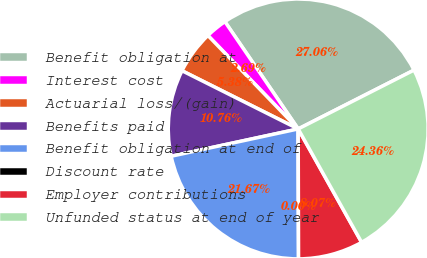Convert chart. <chart><loc_0><loc_0><loc_500><loc_500><pie_chart><fcel>Benefit obligation at<fcel>Interest cost<fcel>Actuarial loss/(gain)<fcel>Benefits paid<fcel>Benefit obligation at end of<fcel>Discount rate<fcel>Employer contributions<fcel>Unfunded status at end of year<nl><fcel>27.05%<fcel>2.69%<fcel>5.38%<fcel>10.76%<fcel>21.67%<fcel>0.0%<fcel>8.07%<fcel>24.36%<nl></chart> 